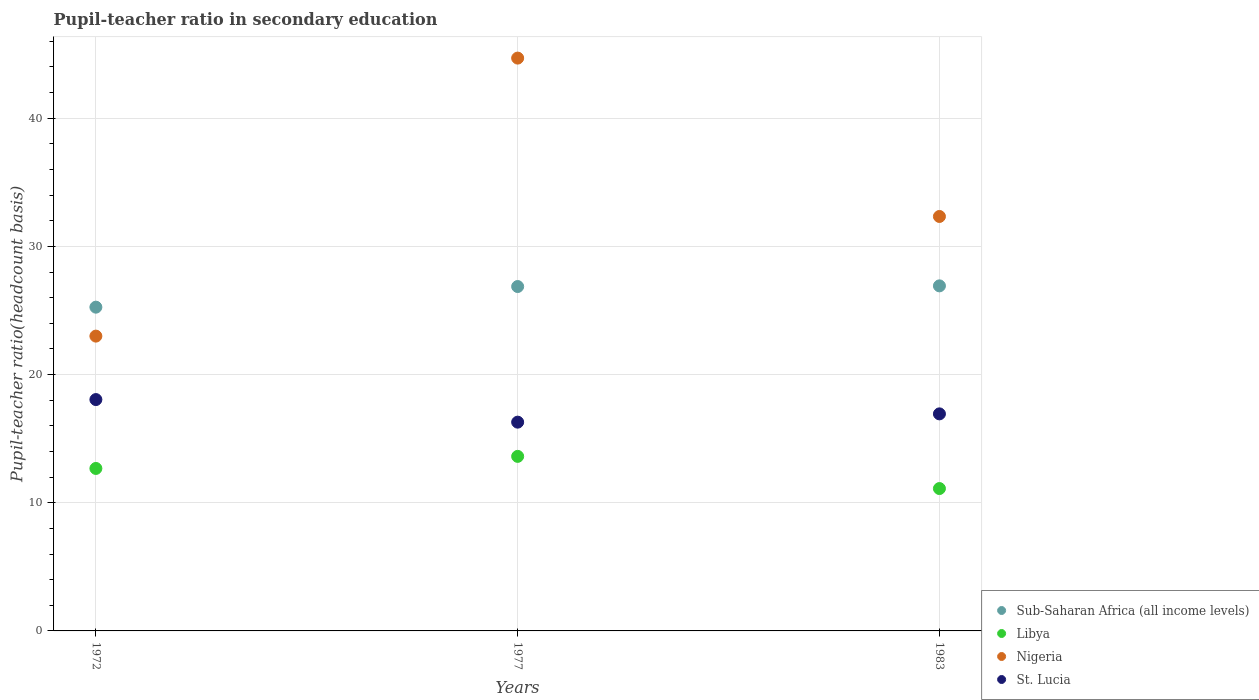How many different coloured dotlines are there?
Keep it short and to the point. 4. What is the pupil-teacher ratio in secondary education in Sub-Saharan Africa (all income levels) in 1977?
Your answer should be compact. 26.87. Across all years, what is the maximum pupil-teacher ratio in secondary education in St. Lucia?
Offer a terse response. 18.05. Across all years, what is the minimum pupil-teacher ratio in secondary education in Libya?
Make the answer very short. 11.11. In which year was the pupil-teacher ratio in secondary education in Nigeria maximum?
Provide a succinct answer. 1977. In which year was the pupil-teacher ratio in secondary education in Libya minimum?
Offer a terse response. 1983. What is the total pupil-teacher ratio in secondary education in St. Lucia in the graph?
Ensure brevity in your answer.  51.27. What is the difference between the pupil-teacher ratio in secondary education in Nigeria in 1972 and that in 1977?
Provide a short and direct response. -21.69. What is the difference between the pupil-teacher ratio in secondary education in Sub-Saharan Africa (all income levels) in 1983 and the pupil-teacher ratio in secondary education in St. Lucia in 1977?
Ensure brevity in your answer.  10.63. What is the average pupil-teacher ratio in secondary education in St. Lucia per year?
Ensure brevity in your answer.  17.09. In the year 1977, what is the difference between the pupil-teacher ratio in secondary education in Nigeria and pupil-teacher ratio in secondary education in St. Lucia?
Ensure brevity in your answer.  28.4. What is the ratio of the pupil-teacher ratio in secondary education in Libya in 1977 to that in 1983?
Offer a terse response. 1.23. Is the pupil-teacher ratio in secondary education in Sub-Saharan Africa (all income levels) in 1972 less than that in 1977?
Provide a succinct answer. Yes. What is the difference between the highest and the second highest pupil-teacher ratio in secondary education in St. Lucia?
Your response must be concise. 1.12. What is the difference between the highest and the lowest pupil-teacher ratio in secondary education in Nigeria?
Your response must be concise. 21.69. In how many years, is the pupil-teacher ratio in secondary education in Nigeria greater than the average pupil-teacher ratio in secondary education in Nigeria taken over all years?
Your answer should be compact. 1. Is the sum of the pupil-teacher ratio in secondary education in Sub-Saharan Africa (all income levels) in 1972 and 1983 greater than the maximum pupil-teacher ratio in secondary education in Libya across all years?
Your answer should be compact. Yes. Is it the case that in every year, the sum of the pupil-teacher ratio in secondary education in Libya and pupil-teacher ratio in secondary education in Sub-Saharan Africa (all income levels)  is greater than the pupil-teacher ratio in secondary education in St. Lucia?
Offer a terse response. Yes. Does the pupil-teacher ratio in secondary education in St. Lucia monotonically increase over the years?
Provide a succinct answer. No. How many years are there in the graph?
Offer a terse response. 3. What is the difference between two consecutive major ticks on the Y-axis?
Offer a very short reply. 10. Are the values on the major ticks of Y-axis written in scientific E-notation?
Ensure brevity in your answer.  No. Does the graph contain any zero values?
Keep it short and to the point. No. How many legend labels are there?
Give a very brief answer. 4. How are the legend labels stacked?
Give a very brief answer. Vertical. What is the title of the graph?
Provide a short and direct response. Pupil-teacher ratio in secondary education. What is the label or title of the Y-axis?
Your response must be concise. Pupil-teacher ratio(headcount basis). What is the Pupil-teacher ratio(headcount basis) of Sub-Saharan Africa (all income levels) in 1972?
Offer a very short reply. 25.26. What is the Pupil-teacher ratio(headcount basis) in Libya in 1972?
Your response must be concise. 12.68. What is the Pupil-teacher ratio(headcount basis) of Nigeria in 1972?
Keep it short and to the point. 23. What is the Pupil-teacher ratio(headcount basis) in St. Lucia in 1972?
Your answer should be compact. 18.05. What is the Pupil-teacher ratio(headcount basis) of Sub-Saharan Africa (all income levels) in 1977?
Your answer should be very brief. 26.87. What is the Pupil-teacher ratio(headcount basis) of Libya in 1977?
Offer a very short reply. 13.62. What is the Pupil-teacher ratio(headcount basis) of Nigeria in 1977?
Your answer should be very brief. 44.69. What is the Pupil-teacher ratio(headcount basis) in St. Lucia in 1977?
Your answer should be very brief. 16.29. What is the Pupil-teacher ratio(headcount basis) of Sub-Saharan Africa (all income levels) in 1983?
Keep it short and to the point. 26.92. What is the Pupil-teacher ratio(headcount basis) in Libya in 1983?
Provide a succinct answer. 11.11. What is the Pupil-teacher ratio(headcount basis) in Nigeria in 1983?
Provide a short and direct response. 32.34. What is the Pupil-teacher ratio(headcount basis) in St. Lucia in 1983?
Provide a succinct answer. 16.93. Across all years, what is the maximum Pupil-teacher ratio(headcount basis) in Sub-Saharan Africa (all income levels)?
Your answer should be very brief. 26.92. Across all years, what is the maximum Pupil-teacher ratio(headcount basis) of Libya?
Offer a terse response. 13.62. Across all years, what is the maximum Pupil-teacher ratio(headcount basis) of Nigeria?
Offer a very short reply. 44.69. Across all years, what is the maximum Pupil-teacher ratio(headcount basis) in St. Lucia?
Offer a very short reply. 18.05. Across all years, what is the minimum Pupil-teacher ratio(headcount basis) in Sub-Saharan Africa (all income levels)?
Make the answer very short. 25.26. Across all years, what is the minimum Pupil-teacher ratio(headcount basis) of Libya?
Keep it short and to the point. 11.11. Across all years, what is the minimum Pupil-teacher ratio(headcount basis) of Nigeria?
Offer a terse response. 23. Across all years, what is the minimum Pupil-teacher ratio(headcount basis) of St. Lucia?
Offer a very short reply. 16.29. What is the total Pupil-teacher ratio(headcount basis) of Sub-Saharan Africa (all income levels) in the graph?
Make the answer very short. 79.05. What is the total Pupil-teacher ratio(headcount basis) of Libya in the graph?
Make the answer very short. 37.4. What is the total Pupil-teacher ratio(headcount basis) of Nigeria in the graph?
Your answer should be compact. 100.03. What is the total Pupil-teacher ratio(headcount basis) of St. Lucia in the graph?
Offer a terse response. 51.27. What is the difference between the Pupil-teacher ratio(headcount basis) in Sub-Saharan Africa (all income levels) in 1972 and that in 1977?
Provide a short and direct response. -1.61. What is the difference between the Pupil-teacher ratio(headcount basis) in Libya in 1972 and that in 1977?
Ensure brevity in your answer.  -0.94. What is the difference between the Pupil-teacher ratio(headcount basis) of Nigeria in 1972 and that in 1977?
Ensure brevity in your answer.  -21.69. What is the difference between the Pupil-teacher ratio(headcount basis) in St. Lucia in 1972 and that in 1977?
Give a very brief answer. 1.76. What is the difference between the Pupil-teacher ratio(headcount basis) of Sub-Saharan Africa (all income levels) in 1972 and that in 1983?
Your answer should be compact. -1.66. What is the difference between the Pupil-teacher ratio(headcount basis) in Libya in 1972 and that in 1983?
Make the answer very short. 1.57. What is the difference between the Pupil-teacher ratio(headcount basis) of Nigeria in 1972 and that in 1983?
Your response must be concise. -9.33. What is the difference between the Pupil-teacher ratio(headcount basis) of St. Lucia in 1972 and that in 1983?
Provide a succinct answer. 1.12. What is the difference between the Pupil-teacher ratio(headcount basis) in Sub-Saharan Africa (all income levels) in 1977 and that in 1983?
Your response must be concise. -0.05. What is the difference between the Pupil-teacher ratio(headcount basis) of Libya in 1977 and that in 1983?
Make the answer very short. 2.51. What is the difference between the Pupil-teacher ratio(headcount basis) of Nigeria in 1977 and that in 1983?
Offer a terse response. 12.36. What is the difference between the Pupil-teacher ratio(headcount basis) in St. Lucia in 1977 and that in 1983?
Offer a very short reply. -0.65. What is the difference between the Pupil-teacher ratio(headcount basis) of Sub-Saharan Africa (all income levels) in 1972 and the Pupil-teacher ratio(headcount basis) of Libya in 1977?
Your answer should be very brief. 11.64. What is the difference between the Pupil-teacher ratio(headcount basis) in Sub-Saharan Africa (all income levels) in 1972 and the Pupil-teacher ratio(headcount basis) in Nigeria in 1977?
Ensure brevity in your answer.  -19.43. What is the difference between the Pupil-teacher ratio(headcount basis) of Sub-Saharan Africa (all income levels) in 1972 and the Pupil-teacher ratio(headcount basis) of St. Lucia in 1977?
Offer a very short reply. 8.97. What is the difference between the Pupil-teacher ratio(headcount basis) of Libya in 1972 and the Pupil-teacher ratio(headcount basis) of Nigeria in 1977?
Your response must be concise. -32.02. What is the difference between the Pupil-teacher ratio(headcount basis) of Libya in 1972 and the Pupil-teacher ratio(headcount basis) of St. Lucia in 1977?
Your answer should be compact. -3.61. What is the difference between the Pupil-teacher ratio(headcount basis) in Nigeria in 1972 and the Pupil-teacher ratio(headcount basis) in St. Lucia in 1977?
Your answer should be very brief. 6.71. What is the difference between the Pupil-teacher ratio(headcount basis) of Sub-Saharan Africa (all income levels) in 1972 and the Pupil-teacher ratio(headcount basis) of Libya in 1983?
Your response must be concise. 14.15. What is the difference between the Pupil-teacher ratio(headcount basis) of Sub-Saharan Africa (all income levels) in 1972 and the Pupil-teacher ratio(headcount basis) of Nigeria in 1983?
Make the answer very short. -7.08. What is the difference between the Pupil-teacher ratio(headcount basis) of Sub-Saharan Africa (all income levels) in 1972 and the Pupil-teacher ratio(headcount basis) of St. Lucia in 1983?
Provide a short and direct response. 8.32. What is the difference between the Pupil-teacher ratio(headcount basis) in Libya in 1972 and the Pupil-teacher ratio(headcount basis) in Nigeria in 1983?
Ensure brevity in your answer.  -19.66. What is the difference between the Pupil-teacher ratio(headcount basis) in Libya in 1972 and the Pupil-teacher ratio(headcount basis) in St. Lucia in 1983?
Offer a terse response. -4.26. What is the difference between the Pupil-teacher ratio(headcount basis) of Nigeria in 1972 and the Pupil-teacher ratio(headcount basis) of St. Lucia in 1983?
Keep it short and to the point. 6.07. What is the difference between the Pupil-teacher ratio(headcount basis) of Sub-Saharan Africa (all income levels) in 1977 and the Pupil-teacher ratio(headcount basis) of Libya in 1983?
Make the answer very short. 15.76. What is the difference between the Pupil-teacher ratio(headcount basis) of Sub-Saharan Africa (all income levels) in 1977 and the Pupil-teacher ratio(headcount basis) of Nigeria in 1983?
Offer a terse response. -5.47. What is the difference between the Pupil-teacher ratio(headcount basis) in Sub-Saharan Africa (all income levels) in 1977 and the Pupil-teacher ratio(headcount basis) in St. Lucia in 1983?
Your answer should be compact. 9.93. What is the difference between the Pupil-teacher ratio(headcount basis) in Libya in 1977 and the Pupil-teacher ratio(headcount basis) in Nigeria in 1983?
Your answer should be very brief. -18.72. What is the difference between the Pupil-teacher ratio(headcount basis) in Libya in 1977 and the Pupil-teacher ratio(headcount basis) in St. Lucia in 1983?
Your answer should be very brief. -3.32. What is the difference between the Pupil-teacher ratio(headcount basis) in Nigeria in 1977 and the Pupil-teacher ratio(headcount basis) in St. Lucia in 1983?
Keep it short and to the point. 27.76. What is the average Pupil-teacher ratio(headcount basis) in Sub-Saharan Africa (all income levels) per year?
Your response must be concise. 26.35. What is the average Pupil-teacher ratio(headcount basis) of Libya per year?
Your answer should be very brief. 12.47. What is the average Pupil-teacher ratio(headcount basis) in Nigeria per year?
Give a very brief answer. 33.34. What is the average Pupil-teacher ratio(headcount basis) of St. Lucia per year?
Your response must be concise. 17.09. In the year 1972, what is the difference between the Pupil-teacher ratio(headcount basis) of Sub-Saharan Africa (all income levels) and Pupil-teacher ratio(headcount basis) of Libya?
Offer a very short reply. 12.58. In the year 1972, what is the difference between the Pupil-teacher ratio(headcount basis) in Sub-Saharan Africa (all income levels) and Pupil-teacher ratio(headcount basis) in Nigeria?
Provide a short and direct response. 2.26. In the year 1972, what is the difference between the Pupil-teacher ratio(headcount basis) of Sub-Saharan Africa (all income levels) and Pupil-teacher ratio(headcount basis) of St. Lucia?
Make the answer very short. 7.21. In the year 1972, what is the difference between the Pupil-teacher ratio(headcount basis) of Libya and Pupil-teacher ratio(headcount basis) of Nigeria?
Your answer should be very brief. -10.32. In the year 1972, what is the difference between the Pupil-teacher ratio(headcount basis) of Libya and Pupil-teacher ratio(headcount basis) of St. Lucia?
Keep it short and to the point. -5.37. In the year 1972, what is the difference between the Pupil-teacher ratio(headcount basis) of Nigeria and Pupil-teacher ratio(headcount basis) of St. Lucia?
Make the answer very short. 4.95. In the year 1977, what is the difference between the Pupil-teacher ratio(headcount basis) in Sub-Saharan Africa (all income levels) and Pupil-teacher ratio(headcount basis) in Libya?
Keep it short and to the point. 13.25. In the year 1977, what is the difference between the Pupil-teacher ratio(headcount basis) of Sub-Saharan Africa (all income levels) and Pupil-teacher ratio(headcount basis) of Nigeria?
Make the answer very short. -17.82. In the year 1977, what is the difference between the Pupil-teacher ratio(headcount basis) of Sub-Saharan Africa (all income levels) and Pupil-teacher ratio(headcount basis) of St. Lucia?
Ensure brevity in your answer.  10.58. In the year 1977, what is the difference between the Pupil-teacher ratio(headcount basis) in Libya and Pupil-teacher ratio(headcount basis) in Nigeria?
Your response must be concise. -31.07. In the year 1977, what is the difference between the Pupil-teacher ratio(headcount basis) in Libya and Pupil-teacher ratio(headcount basis) in St. Lucia?
Give a very brief answer. -2.67. In the year 1977, what is the difference between the Pupil-teacher ratio(headcount basis) of Nigeria and Pupil-teacher ratio(headcount basis) of St. Lucia?
Provide a short and direct response. 28.4. In the year 1983, what is the difference between the Pupil-teacher ratio(headcount basis) of Sub-Saharan Africa (all income levels) and Pupil-teacher ratio(headcount basis) of Libya?
Offer a very short reply. 15.81. In the year 1983, what is the difference between the Pupil-teacher ratio(headcount basis) of Sub-Saharan Africa (all income levels) and Pupil-teacher ratio(headcount basis) of Nigeria?
Provide a short and direct response. -5.41. In the year 1983, what is the difference between the Pupil-teacher ratio(headcount basis) in Sub-Saharan Africa (all income levels) and Pupil-teacher ratio(headcount basis) in St. Lucia?
Your response must be concise. 9.99. In the year 1983, what is the difference between the Pupil-teacher ratio(headcount basis) in Libya and Pupil-teacher ratio(headcount basis) in Nigeria?
Make the answer very short. -21.23. In the year 1983, what is the difference between the Pupil-teacher ratio(headcount basis) of Libya and Pupil-teacher ratio(headcount basis) of St. Lucia?
Your answer should be very brief. -5.83. In the year 1983, what is the difference between the Pupil-teacher ratio(headcount basis) in Nigeria and Pupil-teacher ratio(headcount basis) in St. Lucia?
Your answer should be compact. 15.4. What is the ratio of the Pupil-teacher ratio(headcount basis) of Sub-Saharan Africa (all income levels) in 1972 to that in 1977?
Give a very brief answer. 0.94. What is the ratio of the Pupil-teacher ratio(headcount basis) in Libya in 1972 to that in 1977?
Your response must be concise. 0.93. What is the ratio of the Pupil-teacher ratio(headcount basis) in Nigeria in 1972 to that in 1977?
Provide a succinct answer. 0.51. What is the ratio of the Pupil-teacher ratio(headcount basis) of St. Lucia in 1972 to that in 1977?
Offer a terse response. 1.11. What is the ratio of the Pupil-teacher ratio(headcount basis) of Sub-Saharan Africa (all income levels) in 1972 to that in 1983?
Provide a short and direct response. 0.94. What is the ratio of the Pupil-teacher ratio(headcount basis) of Libya in 1972 to that in 1983?
Ensure brevity in your answer.  1.14. What is the ratio of the Pupil-teacher ratio(headcount basis) of Nigeria in 1972 to that in 1983?
Ensure brevity in your answer.  0.71. What is the ratio of the Pupil-teacher ratio(headcount basis) in St. Lucia in 1972 to that in 1983?
Provide a short and direct response. 1.07. What is the ratio of the Pupil-teacher ratio(headcount basis) of Libya in 1977 to that in 1983?
Provide a short and direct response. 1.23. What is the ratio of the Pupil-teacher ratio(headcount basis) of Nigeria in 1977 to that in 1983?
Provide a succinct answer. 1.38. What is the ratio of the Pupil-teacher ratio(headcount basis) in St. Lucia in 1977 to that in 1983?
Your answer should be very brief. 0.96. What is the difference between the highest and the second highest Pupil-teacher ratio(headcount basis) of Sub-Saharan Africa (all income levels)?
Your response must be concise. 0.05. What is the difference between the highest and the second highest Pupil-teacher ratio(headcount basis) in Libya?
Offer a very short reply. 0.94. What is the difference between the highest and the second highest Pupil-teacher ratio(headcount basis) of Nigeria?
Offer a terse response. 12.36. What is the difference between the highest and the second highest Pupil-teacher ratio(headcount basis) in St. Lucia?
Your answer should be very brief. 1.12. What is the difference between the highest and the lowest Pupil-teacher ratio(headcount basis) in Sub-Saharan Africa (all income levels)?
Offer a terse response. 1.66. What is the difference between the highest and the lowest Pupil-teacher ratio(headcount basis) in Libya?
Ensure brevity in your answer.  2.51. What is the difference between the highest and the lowest Pupil-teacher ratio(headcount basis) in Nigeria?
Offer a very short reply. 21.69. What is the difference between the highest and the lowest Pupil-teacher ratio(headcount basis) of St. Lucia?
Offer a very short reply. 1.76. 